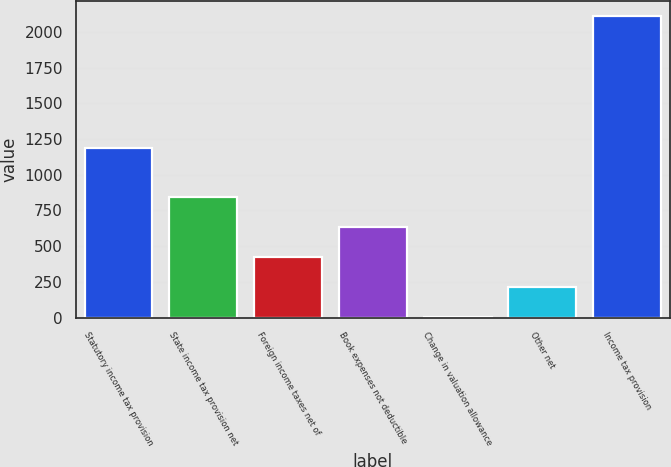<chart> <loc_0><loc_0><loc_500><loc_500><bar_chart><fcel>Statutory income tax provision<fcel>State income tax provision net<fcel>Foreign income taxes net of<fcel>Book expenses not deductible<fcel>Change in valuation allowance<fcel>Other net<fcel>Income tax provision<nl><fcel>1188<fcel>847<fcel>425<fcel>636<fcel>3<fcel>214<fcel>2113<nl></chart> 